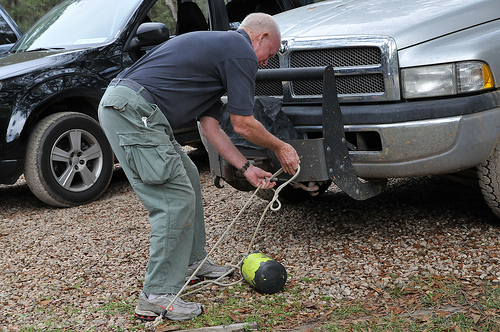How does the setting of the image contribute to the activity being performed? The surroundings, consisting of gravel and grass with vehicles close by, suggest a rural or semi-rural area optimal for outdoor tasks that are not hindered by spatial constraints. 